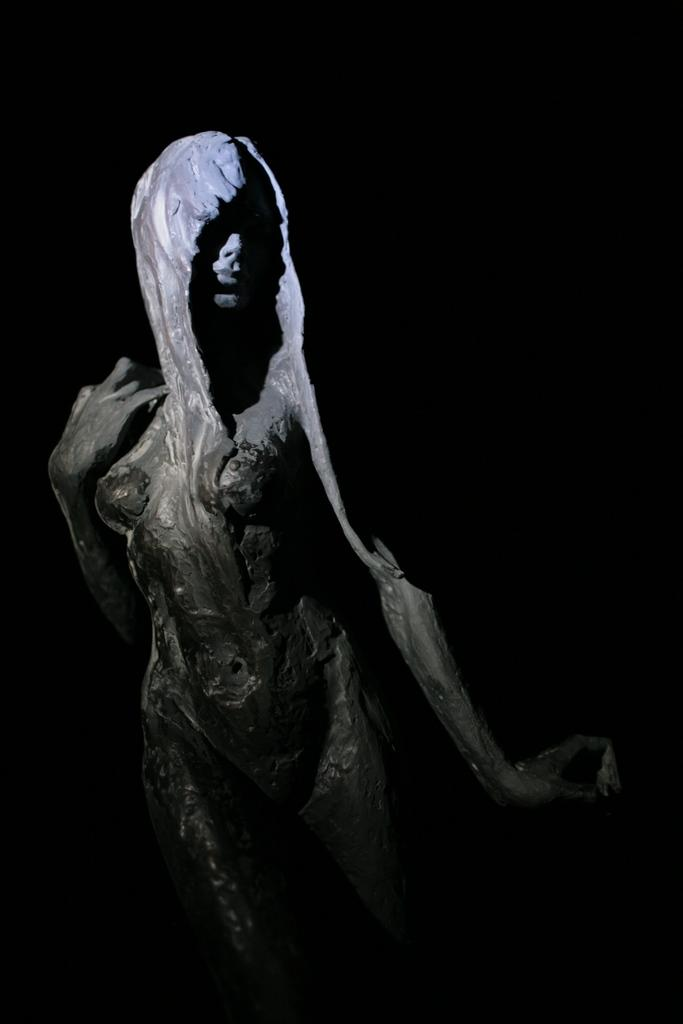What is the main subject of the image? There is a sculpture of a person standing in the image. What can be observed about the background of the image? The background of the image is dark. What type of key is the doctor using to unlock the expert's knowledge in the image? There is no doctor, key, or expert present in the image; it only features a sculpture of a person with a dark background. 